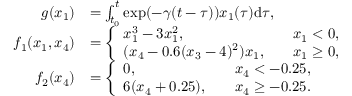Convert formula to latex. <formula><loc_0><loc_0><loc_500><loc_500>\begin{array} { r l } { g ( x _ { 1 } ) } & { = \int _ { t _ { 0 } } ^ { t } \exp ( - \gamma ( t - \tau ) ) x _ { 1 } ( \tau ) d { \tau } , } \\ { f _ { 1 } ( x _ { 1 } , x _ { 4 } ) } & { = \left \{ \begin{array} { l l } { x _ { 1 } ^ { 3 } - 3 x _ { 1 } ^ { 2 } , \quad } & { x _ { 1 } < 0 , } \\ { ( x _ { 4 } - 0 . 6 ( x _ { 3 } - 4 ) ^ { 2 } ) x _ { 1 } , \quad } & { x _ { 1 } \geq 0 , } \end{array} } \\ { f _ { 2 } ( x _ { 4 } ) } & { = \left \{ \begin{array} { l l } { 0 , \quad } & { x _ { 4 } < - 0 . 2 5 , } \\ { 6 ( x _ { 4 } + 0 . 2 5 ) , \quad } & { x _ { 4 } \geq - 0 . 2 5 . } \end{array} } \end{array}</formula> 